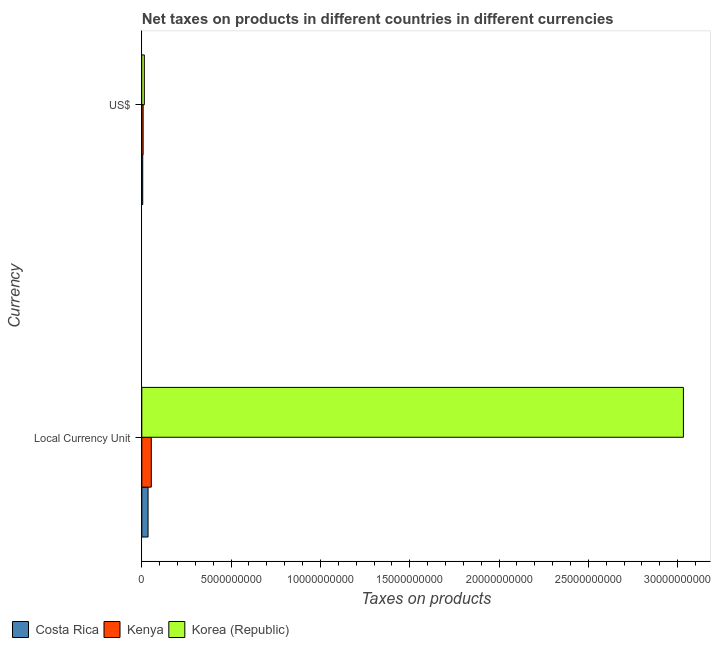How many groups of bars are there?
Give a very brief answer. 2. How many bars are there on the 1st tick from the bottom?
Your answer should be very brief. 3. What is the label of the 1st group of bars from the top?
Offer a terse response. US$. What is the net taxes in constant 2005 us$ in Costa Rica?
Provide a short and direct response. 3.50e+08. Across all countries, what is the maximum net taxes in us$?
Your answer should be very brief. 1.42e+08. Across all countries, what is the minimum net taxes in constant 2005 us$?
Provide a succinct answer. 3.50e+08. In which country was the net taxes in constant 2005 us$ maximum?
Give a very brief answer. Korea (Republic). What is the total net taxes in constant 2005 us$ in the graph?
Keep it short and to the point. 3.12e+1. What is the difference between the net taxes in constant 2005 us$ in Costa Rica and that in Kenya?
Your response must be concise. -1.82e+08. What is the difference between the net taxes in us$ in Korea (Republic) and the net taxes in constant 2005 us$ in Kenya?
Ensure brevity in your answer.  -3.90e+08. What is the average net taxes in us$ per country?
Provide a succinct answer. 8.96e+07. What is the difference between the net taxes in constant 2005 us$ and net taxes in us$ in Costa Rica?
Offer a terse response. 2.98e+08. In how many countries, is the net taxes in us$ greater than 15000000000 units?
Your answer should be compact. 0. What is the ratio of the net taxes in us$ in Costa Rica to that in Kenya?
Keep it short and to the point. 0.71. Is the net taxes in constant 2005 us$ in Korea (Republic) less than that in Kenya?
Provide a succinct answer. No. What does the 2nd bar from the top in US$ represents?
Your answer should be compact. Kenya. What does the 3rd bar from the bottom in US$ represents?
Offer a terse response. Korea (Republic). Are all the bars in the graph horizontal?
Offer a very short reply. Yes. How many countries are there in the graph?
Give a very brief answer. 3. Does the graph contain grids?
Provide a short and direct response. No. How many legend labels are there?
Ensure brevity in your answer.  3. What is the title of the graph?
Your answer should be very brief. Net taxes on products in different countries in different currencies. What is the label or title of the X-axis?
Your answer should be compact. Taxes on products. What is the label or title of the Y-axis?
Offer a terse response. Currency. What is the Taxes on products of Costa Rica in Local Currency Unit?
Your response must be concise. 3.50e+08. What is the Taxes on products in Kenya in Local Currency Unit?
Provide a succinct answer. 5.32e+08. What is the Taxes on products in Korea (Republic) in Local Currency Unit?
Offer a terse response. 3.03e+1. What is the Taxes on products in Costa Rica in US$?
Offer a very short reply. 5.27e+07. What is the Taxes on products in Kenya in US$?
Provide a short and direct response. 7.45e+07. What is the Taxes on products in Korea (Republic) in US$?
Your answer should be compact. 1.42e+08. Across all Currency, what is the maximum Taxes on products in Costa Rica?
Ensure brevity in your answer.  3.50e+08. Across all Currency, what is the maximum Taxes on products of Kenya?
Your answer should be very brief. 5.32e+08. Across all Currency, what is the maximum Taxes on products in Korea (Republic)?
Your answer should be very brief. 3.03e+1. Across all Currency, what is the minimum Taxes on products of Costa Rica?
Your answer should be very brief. 5.27e+07. Across all Currency, what is the minimum Taxes on products in Kenya?
Keep it short and to the point. 7.45e+07. Across all Currency, what is the minimum Taxes on products in Korea (Republic)?
Your answer should be very brief. 1.42e+08. What is the total Taxes on products of Costa Rica in the graph?
Your response must be concise. 4.03e+08. What is the total Taxes on products of Kenya in the graph?
Make the answer very short. 6.06e+08. What is the total Taxes on products of Korea (Republic) in the graph?
Your answer should be very brief. 3.05e+1. What is the difference between the Taxes on products in Costa Rica in Local Currency Unit and that in US$?
Provide a short and direct response. 2.98e+08. What is the difference between the Taxes on products in Kenya in Local Currency Unit and that in US$?
Offer a terse response. 4.58e+08. What is the difference between the Taxes on products of Korea (Republic) in Local Currency Unit and that in US$?
Ensure brevity in your answer.  3.02e+1. What is the difference between the Taxes on products of Costa Rica in Local Currency Unit and the Taxes on products of Kenya in US$?
Keep it short and to the point. 2.76e+08. What is the difference between the Taxes on products in Costa Rica in Local Currency Unit and the Taxes on products in Korea (Republic) in US$?
Offer a terse response. 2.08e+08. What is the difference between the Taxes on products in Kenya in Local Currency Unit and the Taxes on products in Korea (Republic) in US$?
Your answer should be very brief. 3.90e+08. What is the average Taxes on products in Costa Rica per Currency?
Offer a very short reply. 2.01e+08. What is the average Taxes on products of Kenya per Currency?
Provide a succinct answer. 3.03e+08. What is the average Taxes on products of Korea (Republic) per Currency?
Give a very brief answer. 1.52e+1. What is the difference between the Taxes on products of Costa Rica and Taxes on products of Kenya in Local Currency Unit?
Give a very brief answer. -1.82e+08. What is the difference between the Taxes on products of Costa Rica and Taxes on products of Korea (Republic) in Local Currency Unit?
Keep it short and to the point. -3.00e+1. What is the difference between the Taxes on products of Kenya and Taxes on products of Korea (Republic) in Local Currency Unit?
Your answer should be compact. -2.98e+1. What is the difference between the Taxes on products in Costa Rica and Taxes on products in Kenya in US$?
Make the answer very short. -2.18e+07. What is the difference between the Taxes on products in Costa Rica and Taxes on products in Korea (Republic) in US$?
Keep it short and to the point. -8.91e+07. What is the difference between the Taxes on products in Kenya and Taxes on products in Korea (Republic) in US$?
Your answer should be compact. -6.73e+07. What is the ratio of the Taxes on products in Costa Rica in Local Currency Unit to that in US$?
Keep it short and to the point. 6.65. What is the ratio of the Taxes on products of Kenya in Local Currency Unit to that in US$?
Make the answer very short. 7.14. What is the ratio of the Taxes on products in Korea (Republic) in Local Currency Unit to that in US$?
Make the answer very short. 213.85. What is the difference between the highest and the second highest Taxes on products in Costa Rica?
Your answer should be very brief. 2.98e+08. What is the difference between the highest and the second highest Taxes on products of Kenya?
Your response must be concise. 4.58e+08. What is the difference between the highest and the second highest Taxes on products in Korea (Republic)?
Make the answer very short. 3.02e+1. What is the difference between the highest and the lowest Taxes on products in Costa Rica?
Your answer should be very brief. 2.98e+08. What is the difference between the highest and the lowest Taxes on products of Kenya?
Make the answer very short. 4.58e+08. What is the difference between the highest and the lowest Taxes on products in Korea (Republic)?
Keep it short and to the point. 3.02e+1. 